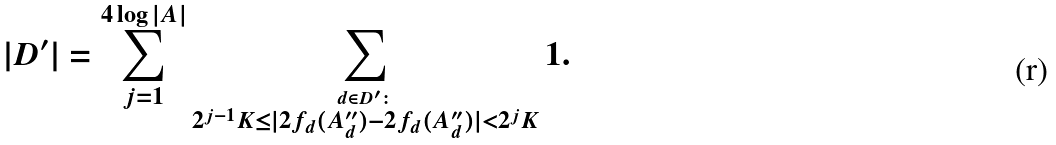<formula> <loc_0><loc_0><loc_500><loc_500>| D ^ { \prime } | = \sum _ { j = 1 } ^ { 4 \log | A | } \sum _ { \stackrel { d \in D ^ { \prime } \colon } { 2 ^ { j - 1 } K \leq | 2 f _ { d } ( A _ { d } ^ { \prime \prime } ) - 2 f _ { d } ( A _ { d } ^ { \prime \prime } ) | < 2 ^ { j } K } } 1 .</formula> 